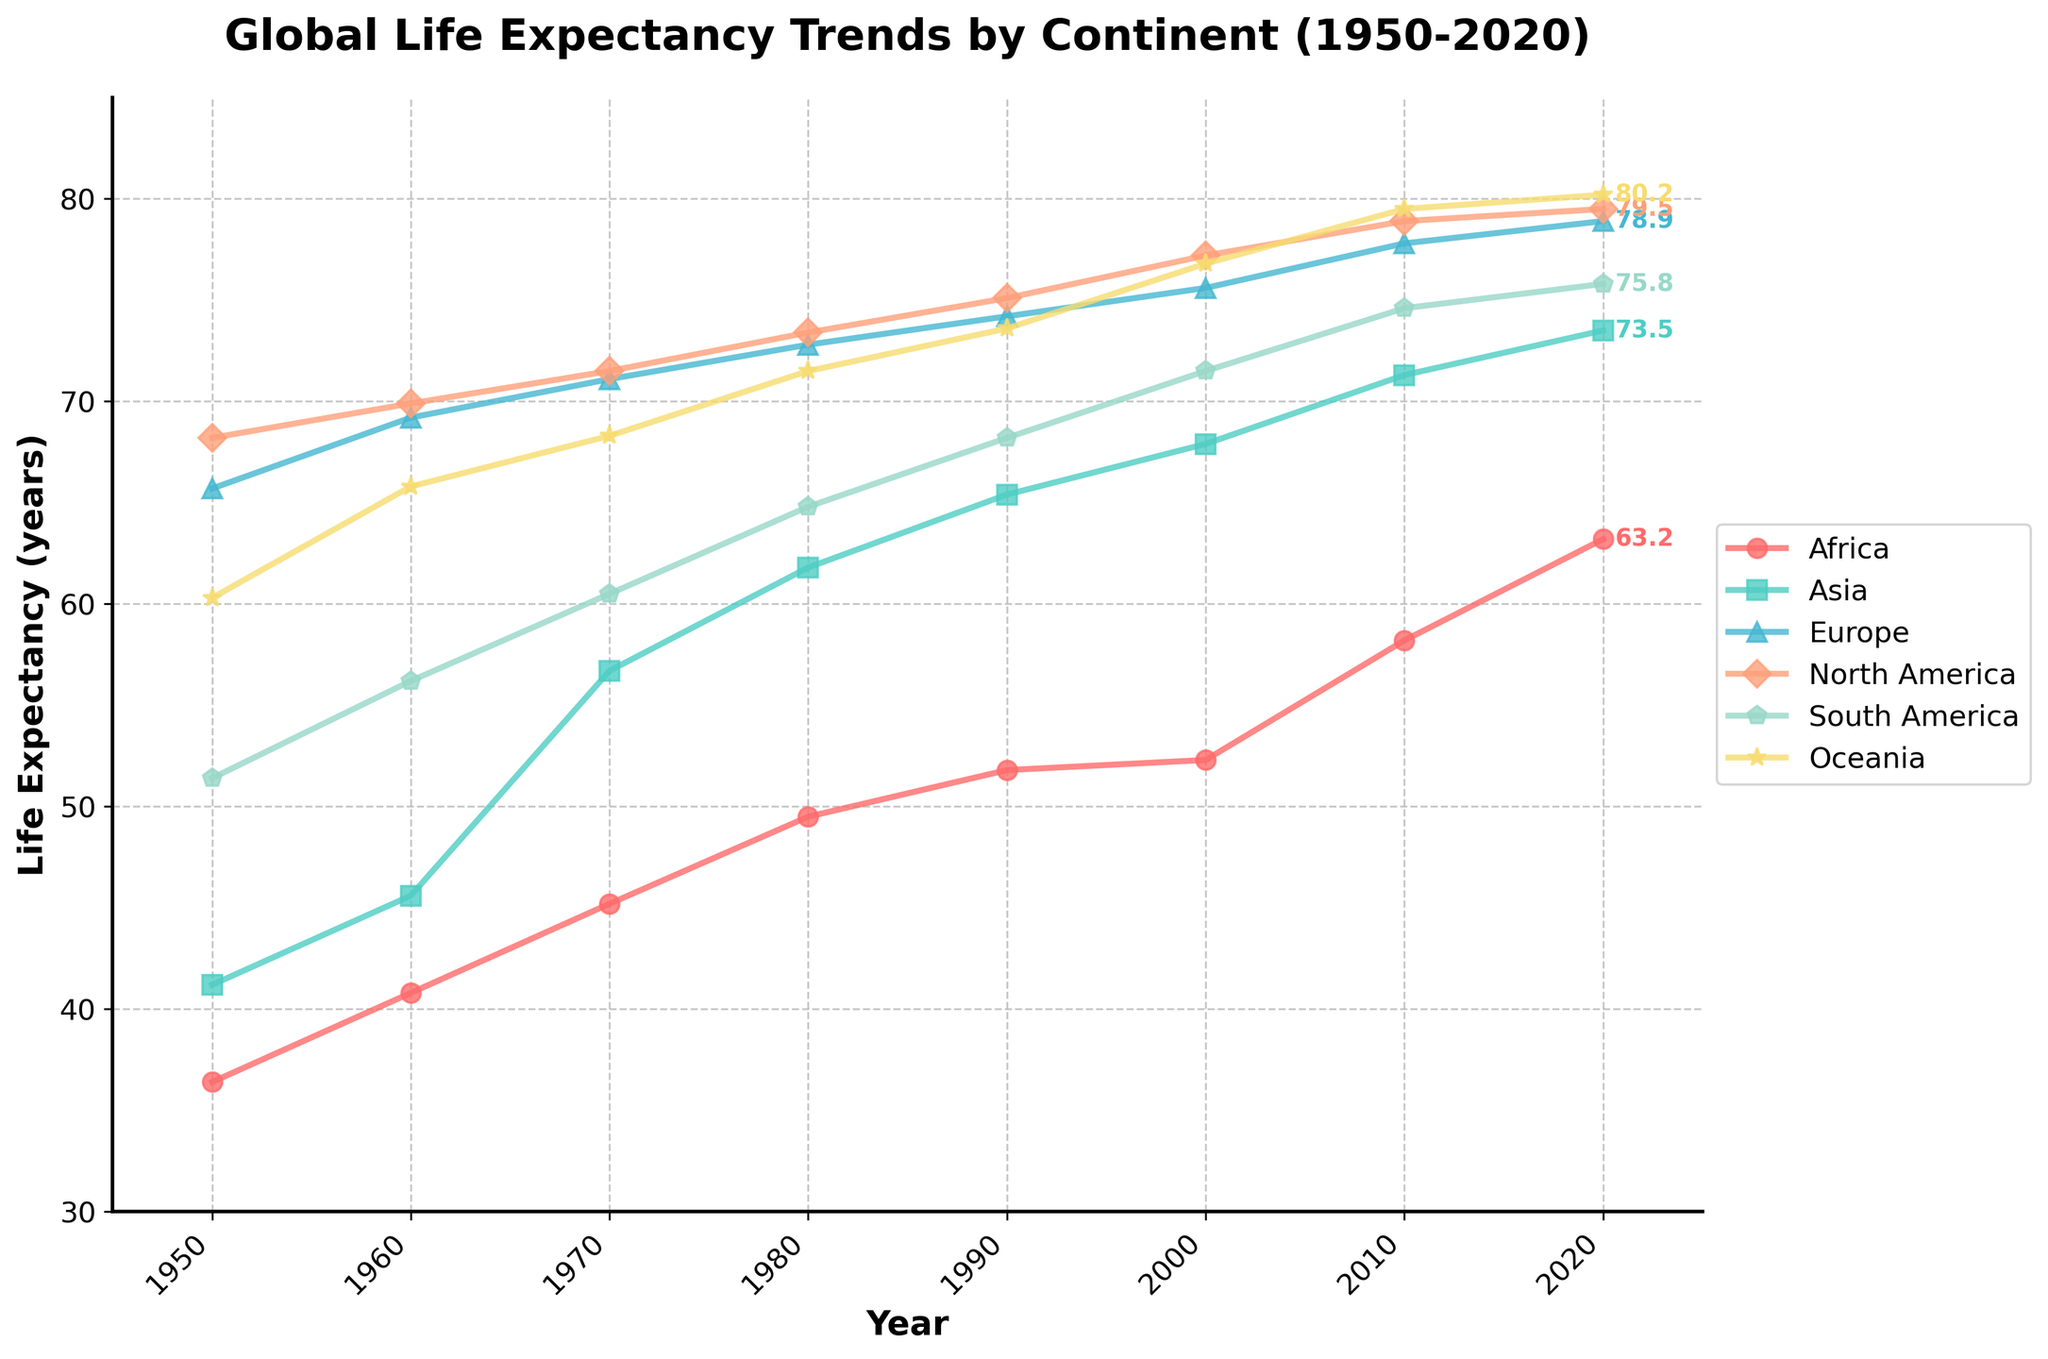What was the life expectancy increase in Africa from 1950 to 2020? To find the increase, subtract the life expectancy in Africa in 1950 from that in 2020. This is 63.2 (in 2020) - 36.4 (in 1950) = 26.8 years.
Answer: 26.8 years Which continent had the highest life expectancy in 2020? Look at the values of life expectancy for each continent in 2020. The highest value is 80.2, which is for Oceania.
Answer: Oceania Between 1950 and 2020, which continent showed the most significant improvement in life expectancy? Calculate the life expectancy increase for each continent from 1950 to 2020 by subtracting the 1950 value from the 2020 value. The largest improvement is in Asia (73.5 - 41.2 = 32.3 years).
Answer: Asia In 1980, which continent had a lower life expectancy: South America or Africa? Compare the life expectancy values for South America and Africa in 1980. South America had 64.8 years, and Africa had 49.5 years. Africa had a lower life expectancy.
Answer: Africa How does the life expectancy trend in Europe compare to that in Asia from 1950 to 2020? Examine the trend lines for Europe and Asia. Both show an upward trend, with Europe's life expectancy starting higher and remaining higher throughout the period, but Asia shows a more significant relative increase.
Answer: Europe consistently higher, but Asia shows greater relative improvement What is the average life expectancy across all continents in the year 2000? Add the life expectancy values for all continents in 2000 and divide by the number of continents: (52.3 + 67.9 + 75.6 + 77.2 + 71.5 + 76.8) / 6 = 70.225 years.
Answer: 70.22 years Which continent had the smallest increase in life expectancy from 1950 to 2020? Calculate the increase for each continent. The smallest increase is in Europe (78.9 - 65.7 = 13.2 years).
Answer: Europe In which decade did Asia experience the most significant life expectancy increase? Compare the life expectancy values for Asia for each decade and find the largest decade-to-decade increase. The most significant increase was from 1960 to 1970 (56.7 - 45.6 = 11.1 years).
Answer: 1960 to 1970 How many continents had a life expectancy of over 75 years by 2020? Count the number of continents with life expectancy values greater than 75 in the year 2020. Oceania (80.2), North America (79.5), Europe (78.9), Asia (73.5) and South America (75.8) had over 75 years (5 continents).
Answer: 5 